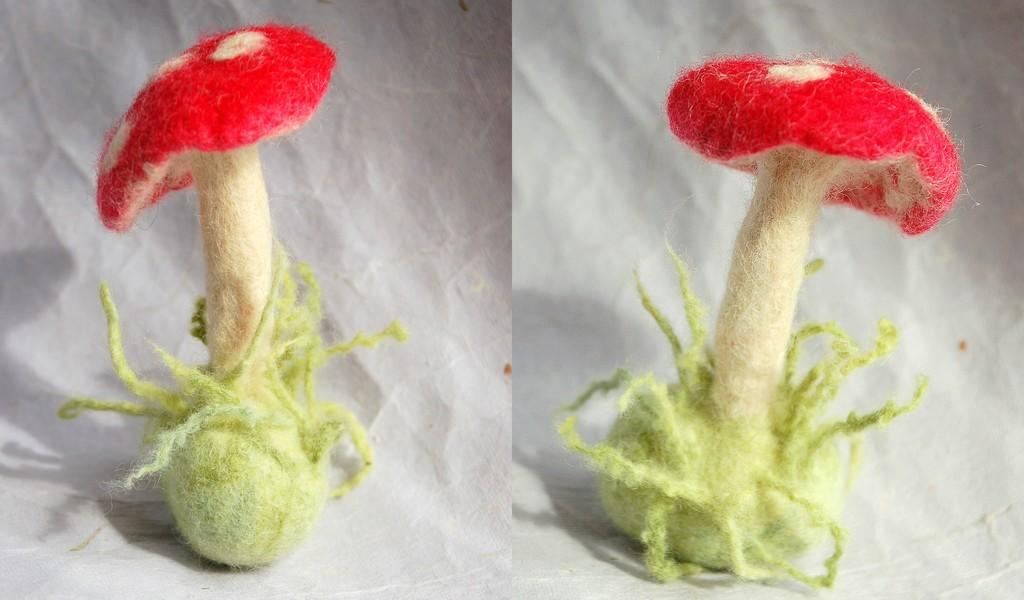How many photos are present in the image? There are two photos in the image. What do the photos depict? The photos depict red-colored mushrooms. What type of reading material is visible in the image? There is no reading material present in the image; it only contains two photos of red-colored mushrooms. Can you see a vase or balloon in the image? No, there is no vase or balloon present in the image. 